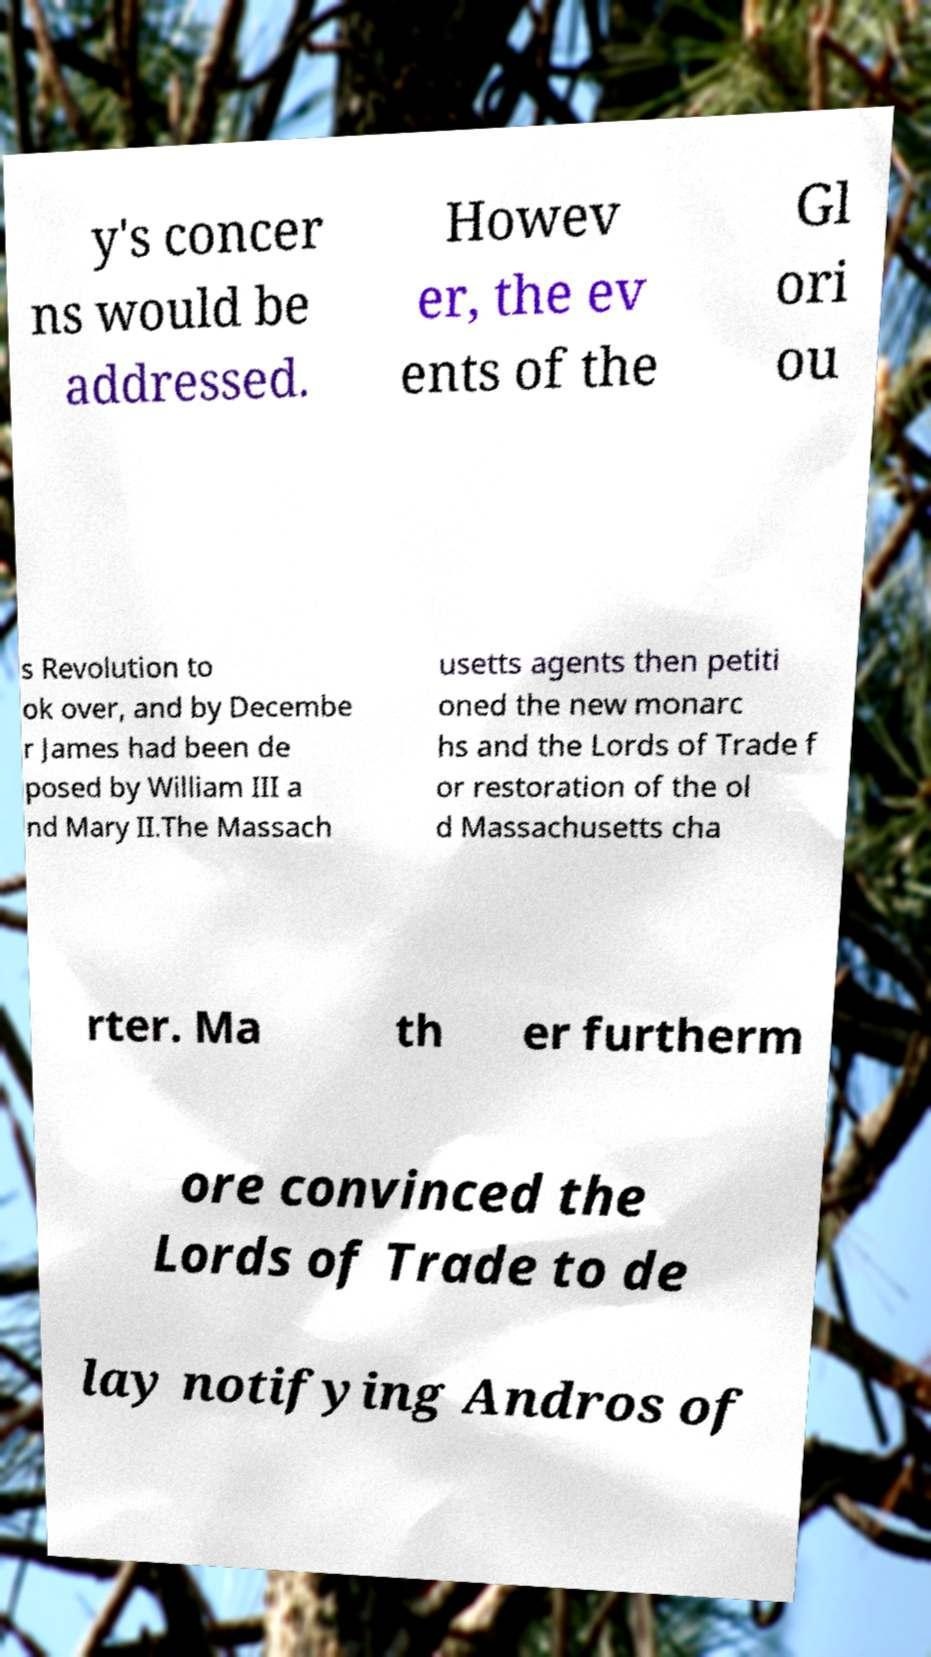Please identify and transcribe the text found in this image. y's concer ns would be addressed. Howev er, the ev ents of the Gl ori ou s Revolution to ok over, and by Decembe r James had been de posed by William III a nd Mary II.The Massach usetts agents then petiti oned the new monarc hs and the Lords of Trade f or restoration of the ol d Massachusetts cha rter. Ma th er furtherm ore convinced the Lords of Trade to de lay notifying Andros of 